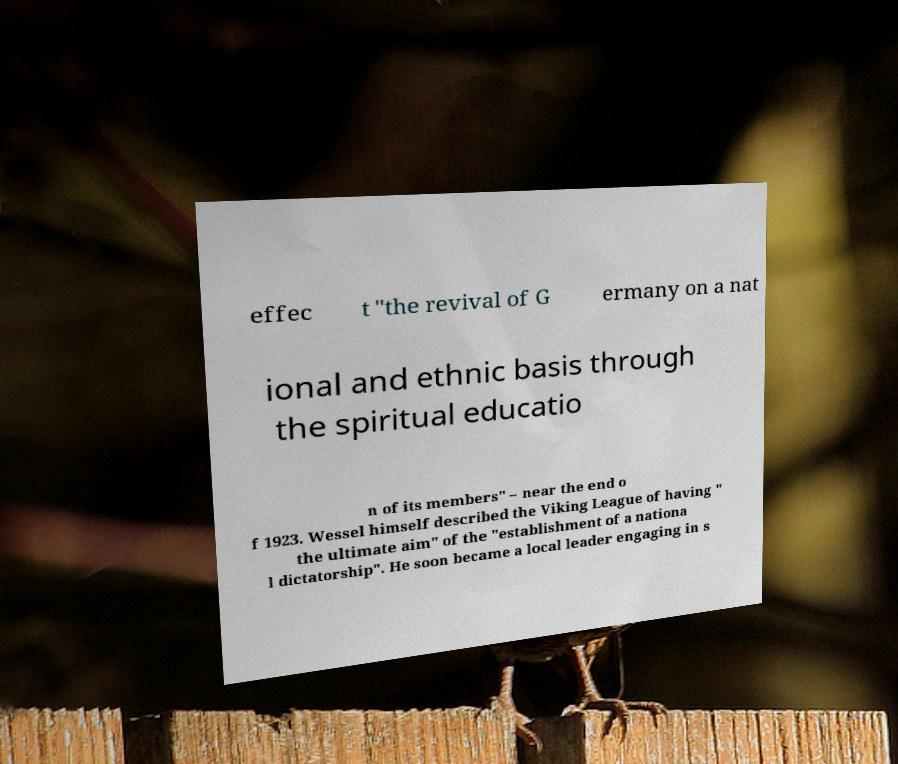I need the written content from this picture converted into text. Can you do that? effec t "the revival of G ermany on a nat ional and ethnic basis through the spiritual educatio n of its members" – near the end o f 1923. Wessel himself described the Viking League of having " the ultimate aim" of the "establishment of a nationa l dictatorship". He soon became a local leader engaging in s 